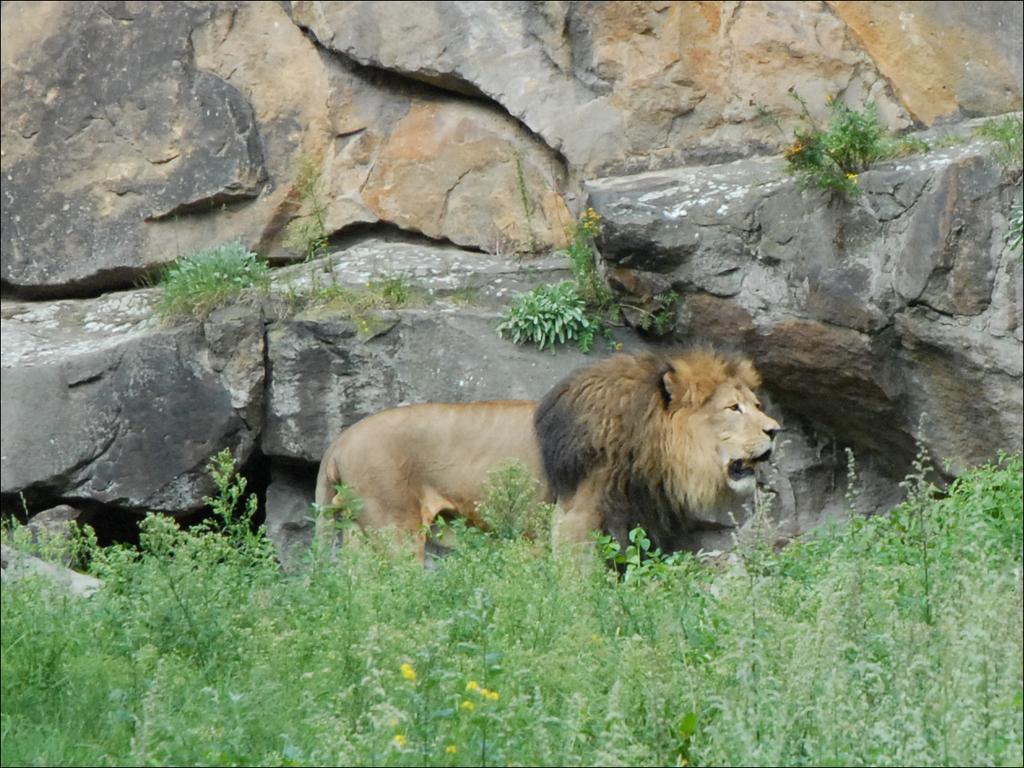In one or two sentences, can you explain what this image depicts? In this image we can see a lion. There are plants at the bottom of the image. In the background, we can see the rocks. 